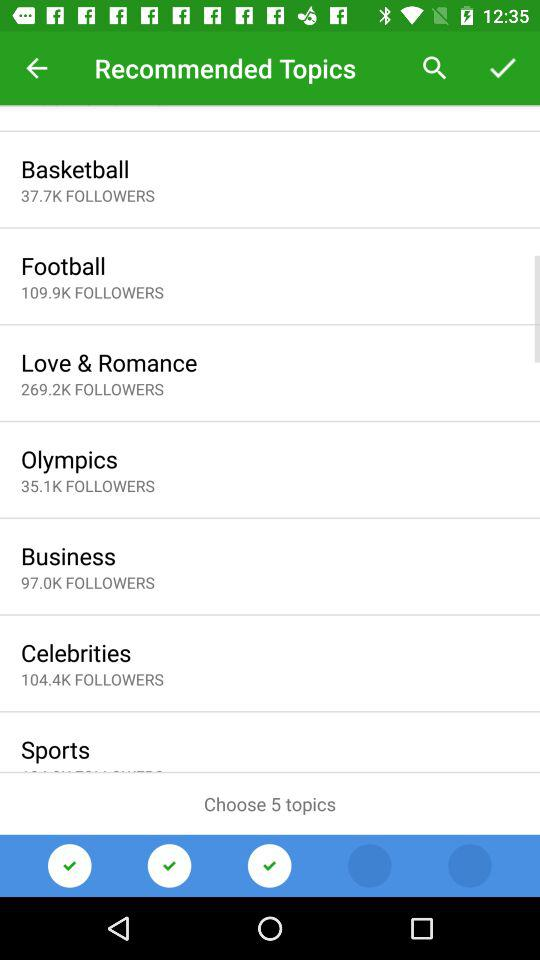How many topics need to be chosen? There are 5 topics that need to be chosen. 